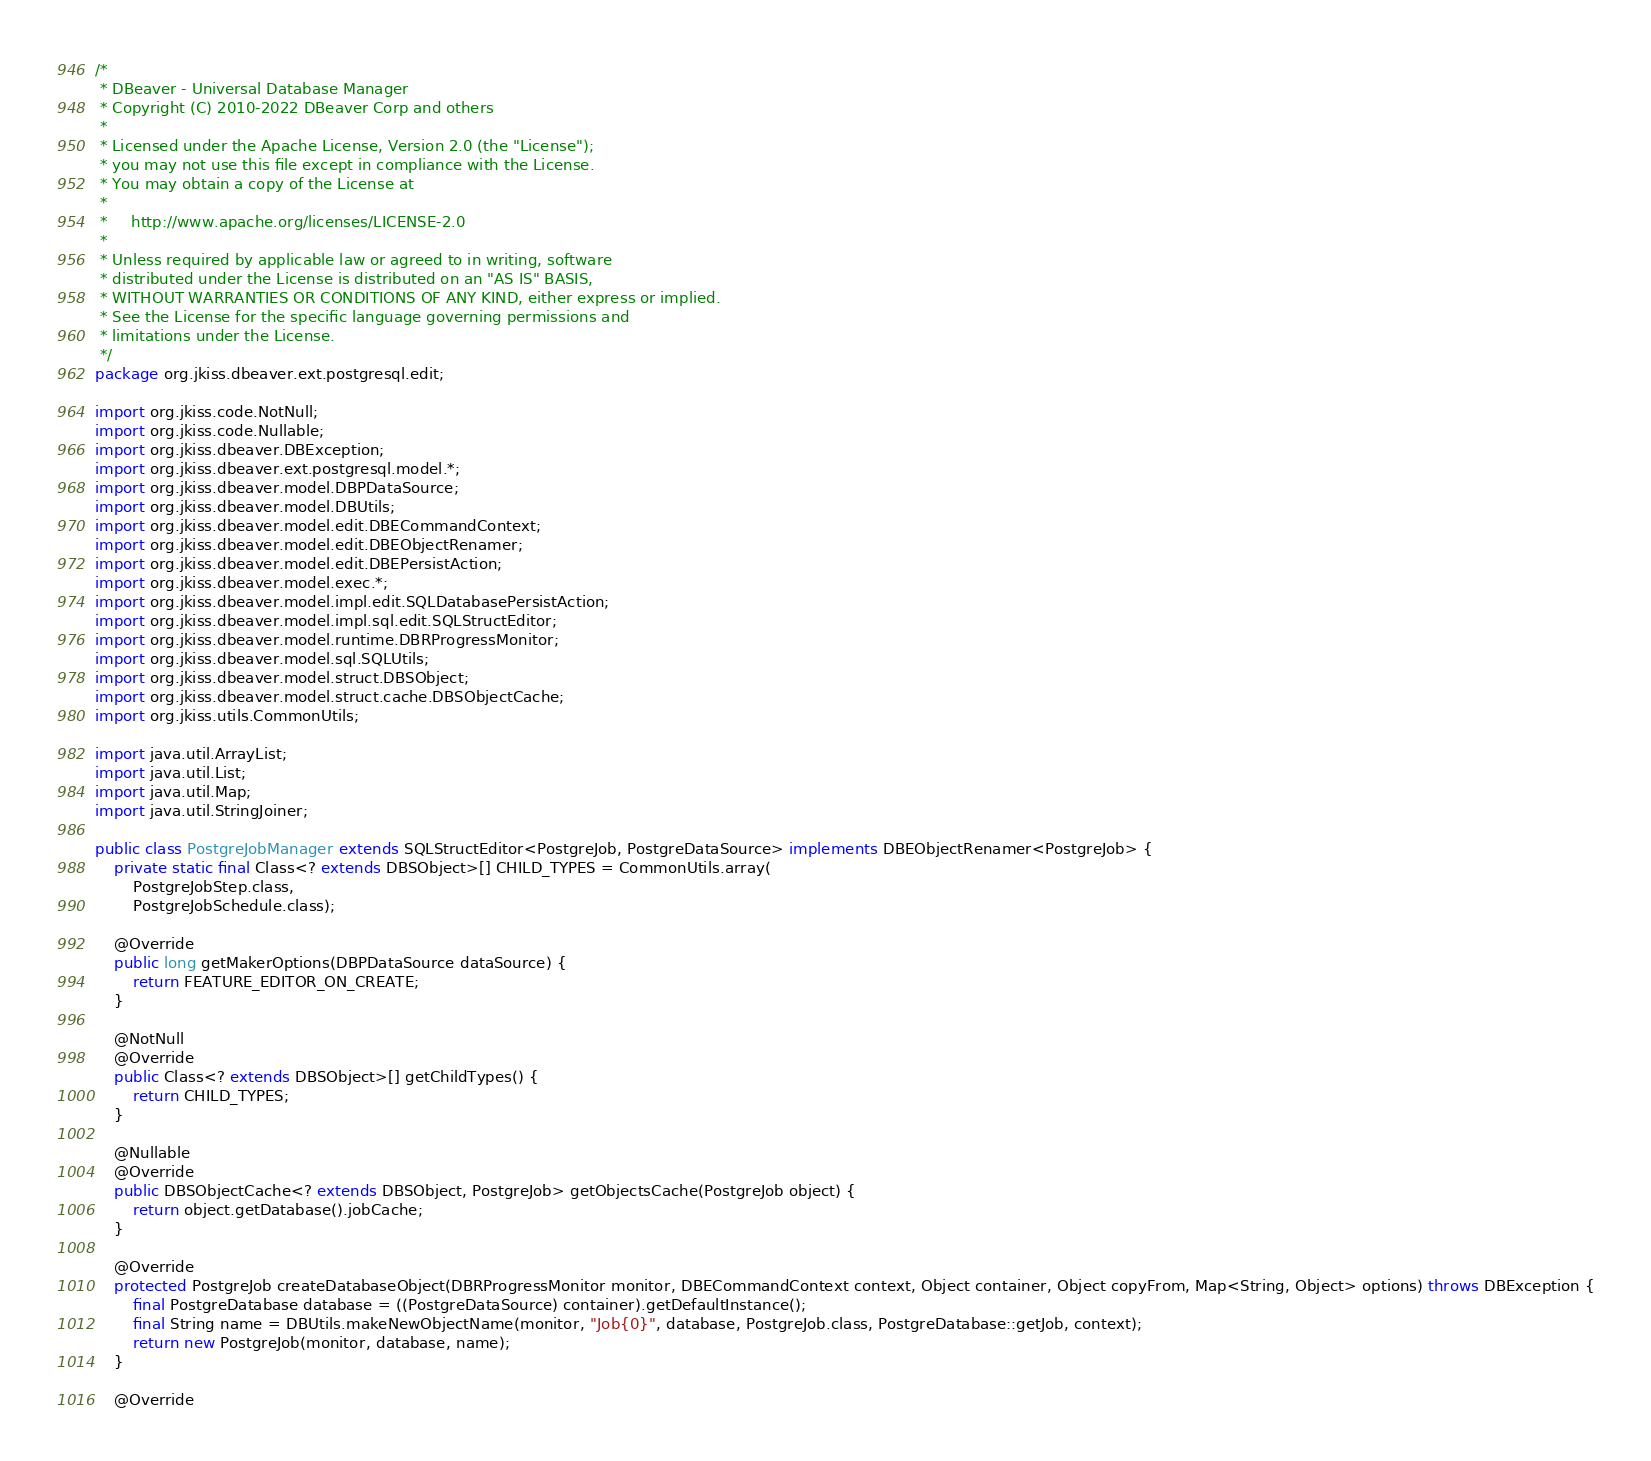Convert code to text. <code><loc_0><loc_0><loc_500><loc_500><_Java_>/*
 * DBeaver - Universal Database Manager
 * Copyright (C) 2010-2022 DBeaver Corp and others
 *
 * Licensed under the Apache License, Version 2.0 (the "License");
 * you may not use this file except in compliance with the License.
 * You may obtain a copy of the License at
 *
 *     http://www.apache.org/licenses/LICENSE-2.0
 *
 * Unless required by applicable law or agreed to in writing, software
 * distributed under the License is distributed on an "AS IS" BASIS,
 * WITHOUT WARRANTIES OR CONDITIONS OF ANY KIND, either express or implied.
 * See the License for the specific language governing permissions and
 * limitations under the License.
 */
package org.jkiss.dbeaver.ext.postgresql.edit;

import org.jkiss.code.NotNull;
import org.jkiss.code.Nullable;
import org.jkiss.dbeaver.DBException;
import org.jkiss.dbeaver.ext.postgresql.model.*;
import org.jkiss.dbeaver.model.DBPDataSource;
import org.jkiss.dbeaver.model.DBUtils;
import org.jkiss.dbeaver.model.edit.DBECommandContext;
import org.jkiss.dbeaver.model.edit.DBEObjectRenamer;
import org.jkiss.dbeaver.model.edit.DBEPersistAction;
import org.jkiss.dbeaver.model.exec.*;
import org.jkiss.dbeaver.model.impl.edit.SQLDatabasePersistAction;
import org.jkiss.dbeaver.model.impl.sql.edit.SQLStructEditor;
import org.jkiss.dbeaver.model.runtime.DBRProgressMonitor;
import org.jkiss.dbeaver.model.sql.SQLUtils;
import org.jkiss.dbeaver.model.struct.DBSObject;
import org.jkiss.dbeaver.model.struct.cache.DBSObjectCache;
import org.jkiss.utils.CommonUtils;

import java.util.ArrayList;
import java.util.List;
import java.util.Map;
import java.util.StringJoiner;

public class PostgreJobManager extends SQLStructEditor<PostgreJob, PostgreDataSource> implements DBEObjectRenamer<PostgreJob> {
    private static final Class<? extends DBSObject>[] CHILD_TYPES = CommonUtils.array(
        PostgreJobStep.class,
        PostgreJobSchedule.class);

    @Override
    public long getMakerOptions(DBPDataSource dataSource) {
        return FEATURE_EDITOR_ON_CREATE;
    }

    @NotNull
    @Override
    public Class<? extends DBSObject>[] getChildTypes() {
        return CHILD_TYPES;
    }

    @Nullable
    @Override
    public DBSObjectCache<? extends DBSObject, PostgreJob> getObjectsCache(PostgreJob object) {
        return object.getDatabase().jobCache;
    }

    @Override
    protected PostgreJob createDatabaseObject(DBRProgressMonitor monitor, DBECommandContext context, Object container, Object copyFrom, Map<String, Object> options) throws DBException {
        final PostgreDatabase database = ((PostgreDataSource) container).getDefaultInstance();
        final String name = DBUtils.makeNewObjectName(monitor, "Job{0}", database, PostgreJob.class, PostgreDatabase::getJob, context);
        return new PostgreJob(monitor, database, name);
    }

    @Override</code> 